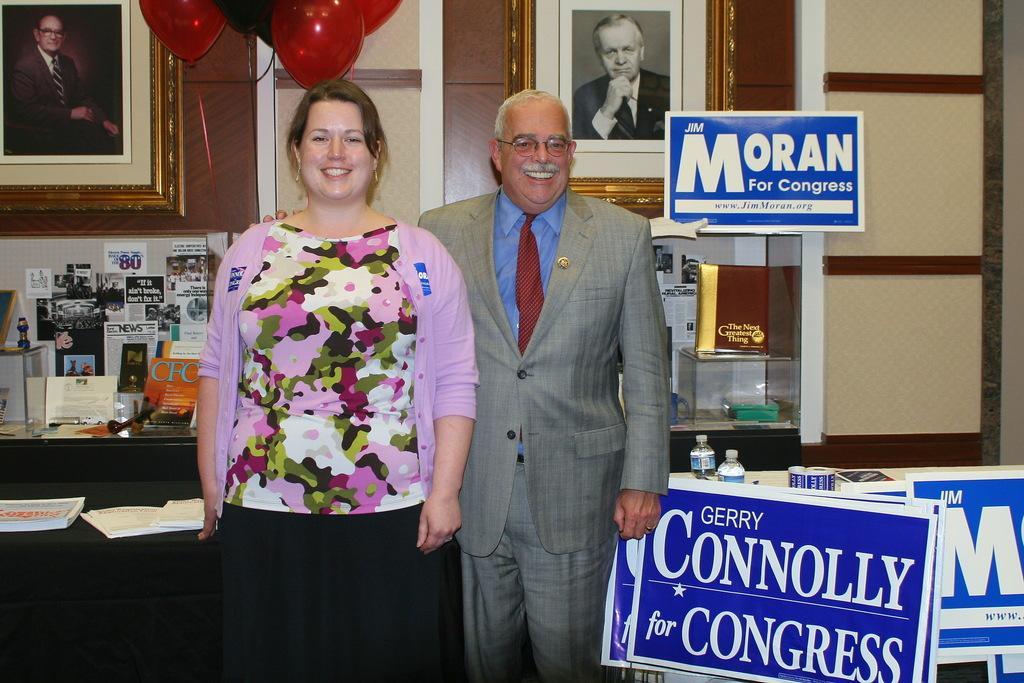Describe this image in one or two sentences. In this image, there is a man and a lady standing, in the background there are tables, on that tables there are few objects and there is a wall, for that wall there are photo frames, at the top there are balloon, near the men there are banners on that banners there is some text. 